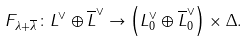<formula> <loc_0><loc_0><loc_500><loc_500>F _ { \lambda + \overline { \lambda } } \colon L ^ { \vee } \oplus \overline { L } ^ { \vee } \rightarrow \left ( L _ { 0 } ^ { \vee } \oplus \overline { L } _ { 0 } ^ { \vee } \right ) \times \Delta .</formula> 